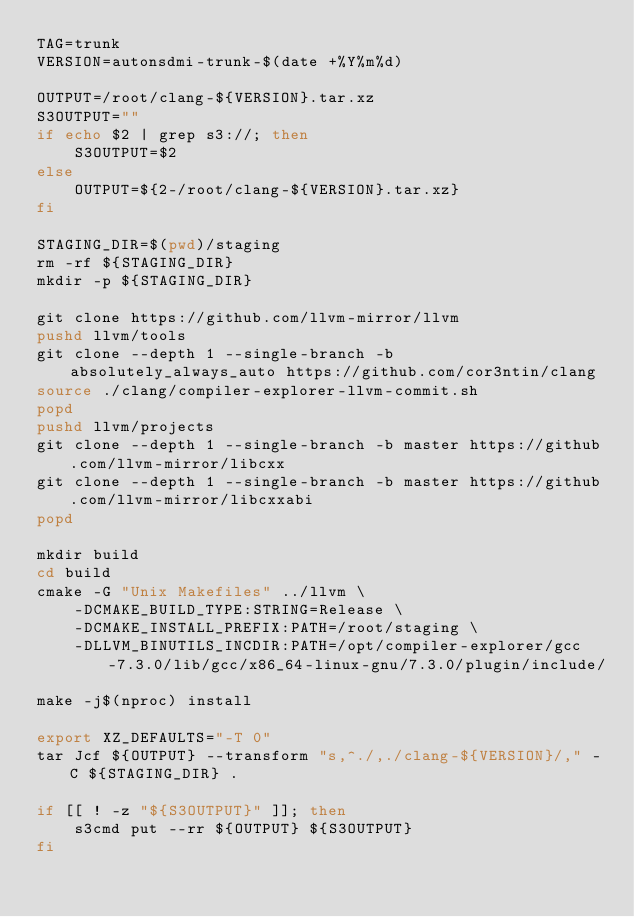<code> <loc_0><loc_0><loc_500><loc_500><_Bash_>TAG=trunk
VERSION=autonsdmi-trunk-$(date +%Y%m%d)

OUTPUT=/root/clang-${VERSION}.tar.xz
S3OUTPUT=""
if echo $2 | grep s3://; then
    S3OUTPUT=$2
else
    OUTPUT=${2-/root/clang-${VERSION}.tar.xz}
fi

STAGING_DIR=$(pwd)/staging
rm -rf ${STAGING_DIR}
mkdir -p ${STAGING_DIR}

git clone https://github.com/llvm-mirror/llvm
pushd llvm/tools
git clone --depth 1 --single-branch -b absolutely_always_auto https://github.com/cor3ntin/clang
source ./clang/compiler-explorer-llvm-commit.sh
popd
pushd llvm/projects
git clone --depth 1 --single-branch -b master https://github.com/llvm-mirror/libcxx
git clone --depth 1 --single-branch -b master https://github.com/llvm-mirror/libcxxabi
popd

mkdir build
cd build
cmake -G "Unix Makefiles" ../llvm \
    -DCMAKE_BUILD_TYPE:STRING=Release \
    -DCMAKE_INSTALL_PREFIX:PATH=/root/staging \
    -DLLVM_BINUTILS_INCDIR:PATH=/opt/compiler-explorer/gcc-7.3.0/lib/gcc/x86_64-linux-gnu/7.3.0/plugin/include/

make -j$(nproc) install

export XZ_DEFAULTS="-T 0"
tar Jcf ${OUTPUT} --transform "s,^./,./clang-${VERSION}/," -C ${STAGING_DIR} .

if [[ ! -z "${S3OUTPUT}" ]]; then
    s3cmd put --rr ${OUTPUT} ${S3OUTPUT}
fi
</code> 